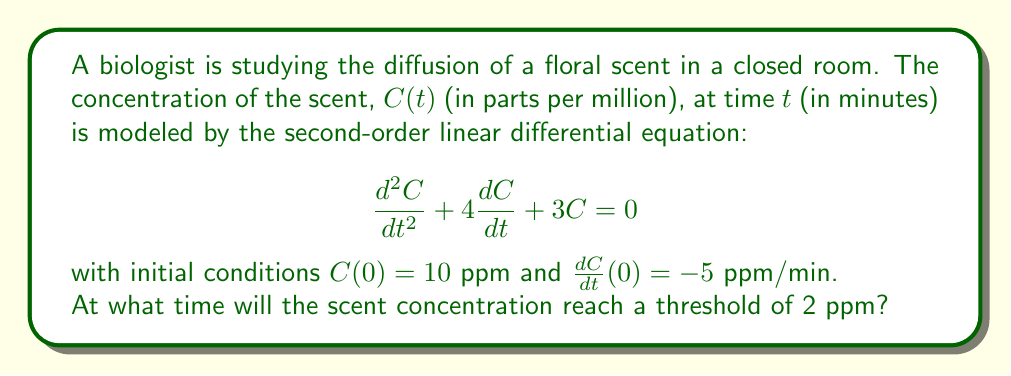Show me your answer to this math problem. To solve this problem, we need to follow these steps:

1) First, we need to solve the second-order linear differential equation. The characteristic equation is:

   $$r^2 + 4r + 3 = 0$$

2) Solving this quadratic equation:
   $$(r + 1)(r + 3) = 0$$
   $r = -1$ or $r = -3$

3) The general solution is therefore:

   $$C(t) = A e^{-t} + B e^{-3t}$$

4) Using the initial conditions to find A and B:

   At $t = 0$: $C(0) = 10 = A + B$
   
   $\frac{dC}{dt} = -A e^{-t} - 3B e^{-3t}$
   At $t = 0$: $\frac{dC}{dt}(0) = -5 = -A - 3B$

5) Solving these simultaneous equations:
   $A + B = 10$
   $A + 3B = 5$
   
   Subtracting the second equation from the first:
   $-2B = 5$
   $B = -2.5$
   
   Substituting back:
   $A + (-2.5) = 10$
   $A = 12.5$

6) Therefore, the particular solution is:

   $$C(t) = 12.5 e^{-t} - 2.5 e^{-3t}$$

7) To find when the concentration reaches 2 ppm, we solve:

   $$2 = 12.5 e^{-t} - 2.5 e^{-3t}$$

8) This transcendental equation cannot be solved algebraically. We need to use numerical methods or graphing to find the solution.

9) Using a graphing calculator or software, we can find that this equation is satisfied when $t \approx 1.6095$ minutes.
Answer: The scent concentration will reach the threshold of 2 ppm after approximately 1.61 minutes. 